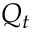<formula> <loc_0><loc_0><loc_500><loc_500>Q _ { t }</formula> 